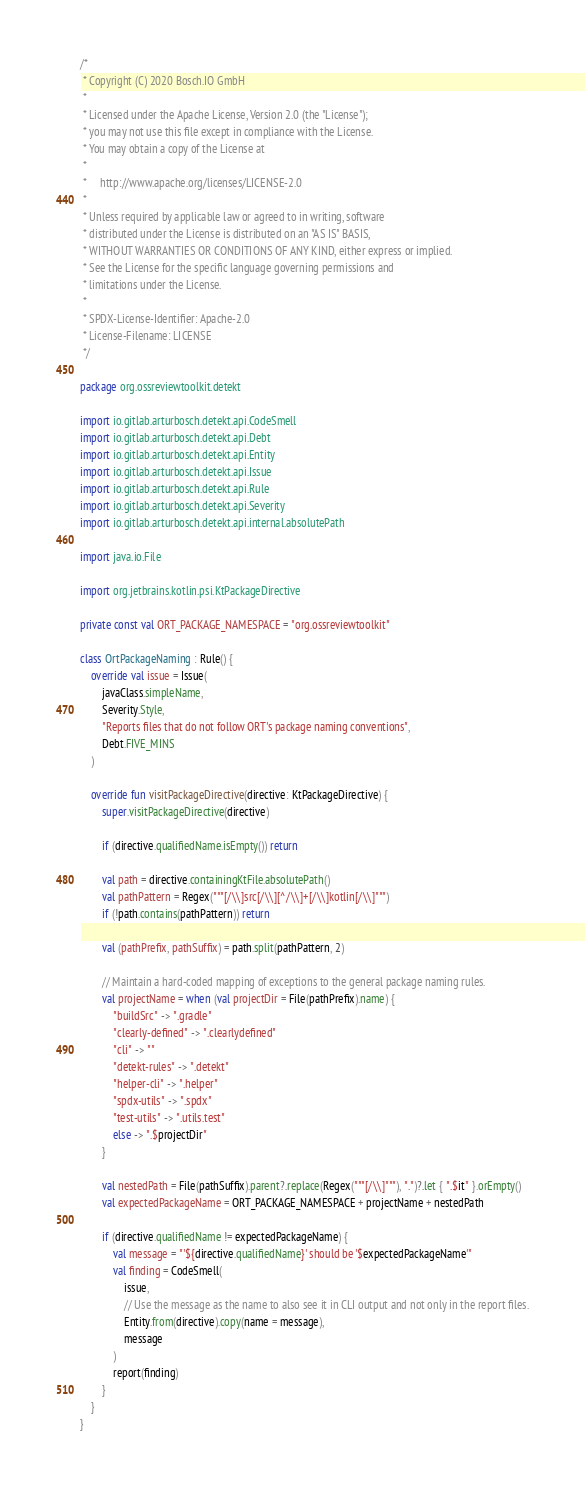Convert code to text. <code><loc_0><loc_0><loc_500><loc_500><_Kotlin_>/*
 * Copyright (C) 2020 Bosch.IO GmbH
 *
 * Licensed under the Apache License, Version 2.0 (the "License");
 * you may not use this file except in compliance with the License.
 * You may obtain a copy of the License at
 *
 *     http://www.apache.org/licenses/LICENSE-2.0
 *
 * Unless required by applicable law or agreed to in writing, software
 * distributed under the License is distributed on an "AS IS" BASIS,
 * WITHOUT WARRANTIES OR CONDITIONS OF ANY KIND, either express or implied.
 * See the License for the specific language governing permissions and
 * limitations under the License.
 *
 * SPDX-License-Identifier: Apache-2.0
 * License-Filename: LICENSE
 */

package org.ossreviewtoolkit.detekt

import io.gitlab.arturbosch.detekt.api.CodeSmell
import io.gitlab.arturbosch.detekt.api.Debt
import io.gitlab.arturbosch.detekt.api.Entity
import io.gitlab.arturbosch.detekt.api.Issue
import io.gitlab.arturbosch.detekt.api.Rule
import io.gitlab.arturbosch.detekt.api.Severity
import io.gitlab.arturbosch.detekt.api.internal.absolutePath

import java.io.File

import org.jetbrains.kotlin.psi.KtPackageDirective

private const val ORT_PACKAGE_NAMESPACE = "org.ossreviewtoolkit"

class OrtPackageNaming : Rule() {
    override val issue = Issue(
        javaClass.simpleName,
        Severity.Style,
        "Reports files that do not follow ORT's package naming conventions",
        Debt.FIVE_MINS
    )

    override fun visitPackageDirective(directive: KtPackageDirective) {
        super.visitPackageDirective(directive)

        if (directive.qualifiedName.isEmpty()) return

        val path = directive.containingKtFile.absolutePath()
        val pathPattern = Regex("""[/\\]src[/\\][^/\\]+[/\\]kotlin[/\\]""")
        if (!path.contains(pathPattern)) return

        val (pathPrefix, pathSuffix) = path.split(pathPattern, 2)

        // Maintain a hard-coded mapping of exceptions to the general package naming rules.
        val projectName = when (val projectDir = File(pathPrefix).name) {
            "buildSrc" -> ".gradle"
            "clearly-defined" -> ".clearlydefined"
            "cli" -> ""
            "detekt-rules" -> ".detekt"
            "helper-cli" -> ".helper"
            "spdx-utils" -> ".spdx"
            "test-utils" -> ".utils.test"
            else -> ".$projectDir"
        }

        val nestedPath = File(pathSuffix).parent?.replace(Regex("""[/\\]"""), ".")?.let { ".$it" }.orEmpty()
        val expectedPackageName = ORT_PACKAGE_NAMESPACE + projectName + nestedPath

        if (directive.qualifiedName != expectedPackageName) {
            val message = "'${directive.qualifiedName}' should be '$expectedPackageName'"
            val finding = CodeSmell(
                issue,
                // Use the message as the name to also see it in CLI output and not only in the report files.
                Entity.from(directive).copy(name = message),
                message
            )
            report(finding)
        }
    }
}
</code> 